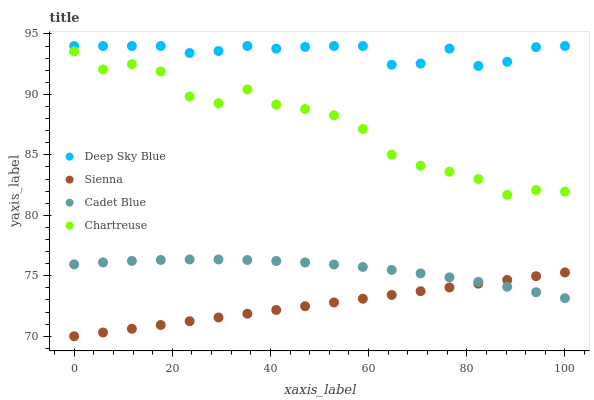Does Sienna have the minimum area under the curve?
Answer yes or no. Yes. Does Deep Sky Blue have the maximum area under the curve?
Answer yes or no. Yes. Does Chartreuse have the minimum area under the curve?
Answer yes or no. No. Does Chartreuse have the maximum area under the curve?
Answer yes or no. No. Is Sienna the smoothest?
Answer yes or no. Yes. Is Chartreuse the roughest?
Answer yes or no. Yes. Is Cadet Blue the smoothest?
Answer yes or no. No. Is Cadet Blue the roughest?
Answer yes or no. No. Does Sienna have the lowest value?
Answer yes or no. Yes. Does Chartreuse have the lowest value?
Answer yes or no. No. Does Deep Sky Blue have the highest value?
Answer yes or no. Yes. Does Chartreuse have the highest value?
Answer yes or no. No. Is Cadet Blue less than Deep Sky Blue?
Answer yes or no. Yes. Is Deep Sky Blue greater than Chartreuse?
Answer yes or no. Yes. Does Sienna intersect Cadet Blue?
Answer yes or no. Yes. Is Sienna less than Cadet Blue?
Answer yes or no. No. Is Sienna greater than Cadet Blue?
Answer yes or no. No. Does Cadet Blue intersect Deep Sky Blue?
Answer yes or no. No. 